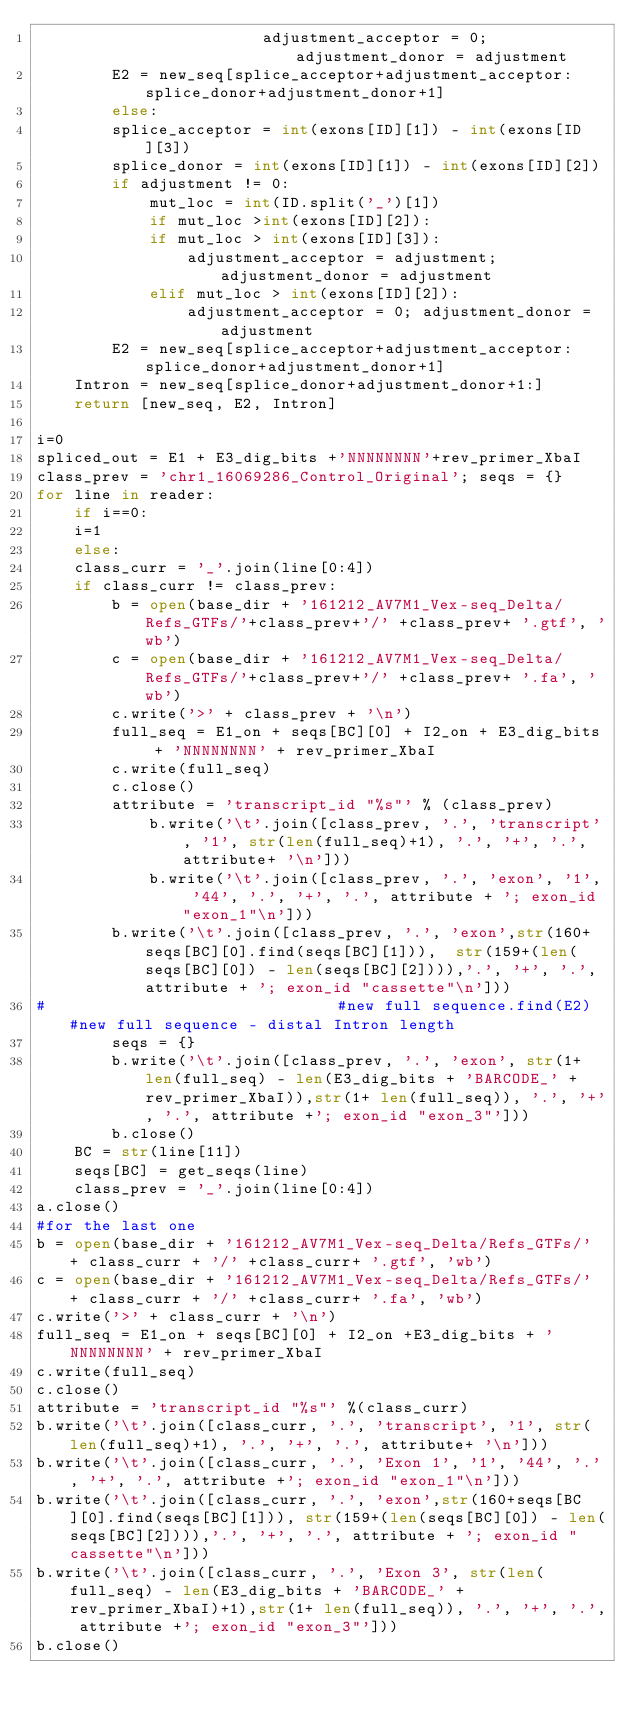Convert code to text. <code><loc_0><loc_0><loc_500><loc_500><_Python_>                    	adjustment_acceptor = 0; adjustment_donor = adjustment
	    E2 = new_seq[splice_acceptor+adjustment_acceptor:splice_donor+adjustment_donor+1]
        else:
	    splice_acceptor = int(exons[ID][1]) - int(exons[ID][3])
	    splice_donor = int(exons[ID][1]) - int(exons[ID][2])
	    if adjustment != 0:
	    	mut_loc = int(ID.split('_')[1])
	    	if mut_loc >int(exons[ID][2]):
		    if mut_loc > int(exons[ID][3]):
		    	adjustment_acceptor = adjustment; adjustment_donor = adjustment
		    elif mut_loc > int(exons[ID][2]):
		    	adjustment_acceptor = 0; adjustment_donor = adjustment
	    E2 = new_seq[splice_acceptor+adjustment_acceptor:splice_donor+adjustment_donor+1]
    Intron = new_seq[splice_donor+adjustment_donor+1:]
    return [new_seq, E2, Intron]

i=0
spliced_out = E1 + E3_dig_bits +'NNNNNNNN'+rev_primer_XbaI
class_prev = 'chr1_16069286_Control_Original'; seqs = {} 
for line in reader:
    if i==0:
	i=1
    else:
	class_curr = '_'.join(line[0:4])
	if class_curr != class_prev:
	    b = open(base_dir + '161212_AV7M1_Vex-seq_Delta/Refs_GTFs/'+class_prev+'/' +class_prev+ '.gtf', 'wb')
	    c = open(base_dir + '161212_AV7M1_Vex-seq_Delta/Refs_GTFs/'+class_prev+'/' +class_prev+ '.fa', 'wb')
	    c.write('>' + class_prev + '\n')
	    full_seq = E1_on + seqs[BC][0] + I2_on + E3_dig_bits + 'NNNNNNNN' + rev_primer_XbaI
	    c.write(full_seq)
	    c.close()
	    attribute = 'transcript_id "%s"' % (class_prev)
            b.write('\t'.join([class_prev, '.', 'transcript', '1', str(len(full_seq)+1), '.', '+', '.', attribute+ '\n']))
            b.write('\t'.join([class_prev, '.', 'exon', '1', '44', '.', '+', '.', attribute + '; exon_id "exon_1"\n']))
	    b.write('\t'.join([class_prev, '.', 'exon',str(160+seqs[BC][0].find(seqs[BC][1])),  str(159+(len(seqs[BC][0]) - len(seqs[BC][2]))),'.', '+', '.', attribute + '; exon_id "cassette"\n']))
#								#new full sequence.find(E2)	#new full sequence - distal Intron length
	    seqs = {}
	    b.write('\t'.join([class_prev, '.', 'exon', str(1+ len(full_seq) - len(E3_dig_bits + 'BARCODE_' + rev_primer_XbaI)),str(1+ len(full_seq)), '.', '+', '.', attribute +'; exon_id "exon_3"']))
	    b.close()
	BC = str(line[11])
	seqs[BC] = get_seqs(line)
	class_prev = '_'.join(line[0:4])
a.close()
#for the last one
b = open(base_dir + '161212_AV7M1_Vex-seq_Delta/Refs_GTFs/' + class_curr + '/' +class_curr+ '.gtf', 'wb')
c = open(base_dir + '161212_AV7M1_Vex-seq_Delta/Refs_GTFs/' + class_curr + '/' +class_curr+ '.fa', 'wb')
c.write('>' + class_curr + '\n')
full_seq = E1_on + seqs[BC][0] + I2_on +E3_dig_bits + 'NNNNNNNN' + rev_primer_XbaI
c.write(full_seq)
c.close()
attribute = 'transcript_id "%s"' %(class_curr)
b.write('\t'.join([class_curr, '.', 'transcript', '1', str(len(full_seq)+1), '.', '+', '.', attribute+ '\n']))
b.write('\t'.join([class_curr, '.', 'Exon 1', '1', '44', '.', '+', '.', attribute +'; exon_id "exon_1"\n']))
b.write('\t'.join([class_curr, '.', 'exon',str(160+seqs[BC][0].find(seqs[BC][1])), str(159+(len(seqs[BC][0]) - len(seqs[BC][2]))),'.', '+', '.', attribute + '; exon_id "cassette"\n']))
b.write('\t'.join([class_curr, '.', 'Exon 3', str(len(full_seq) - len(E3_dig_bits + 'BARCODE_' + rev_primer_XbaI)+1),str(1+ len(full_seq)), '.', '+', '.', attribute +'; exon_id "exon_3"']))
b.close()

</code> 